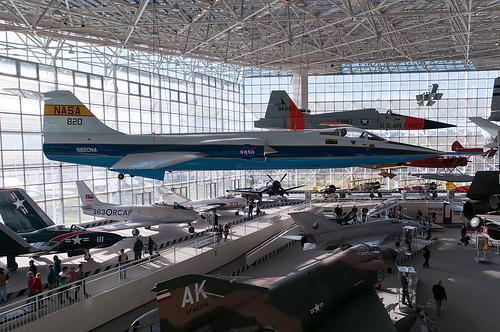How many planes are in the air?
Give a very brief answer. 3. 